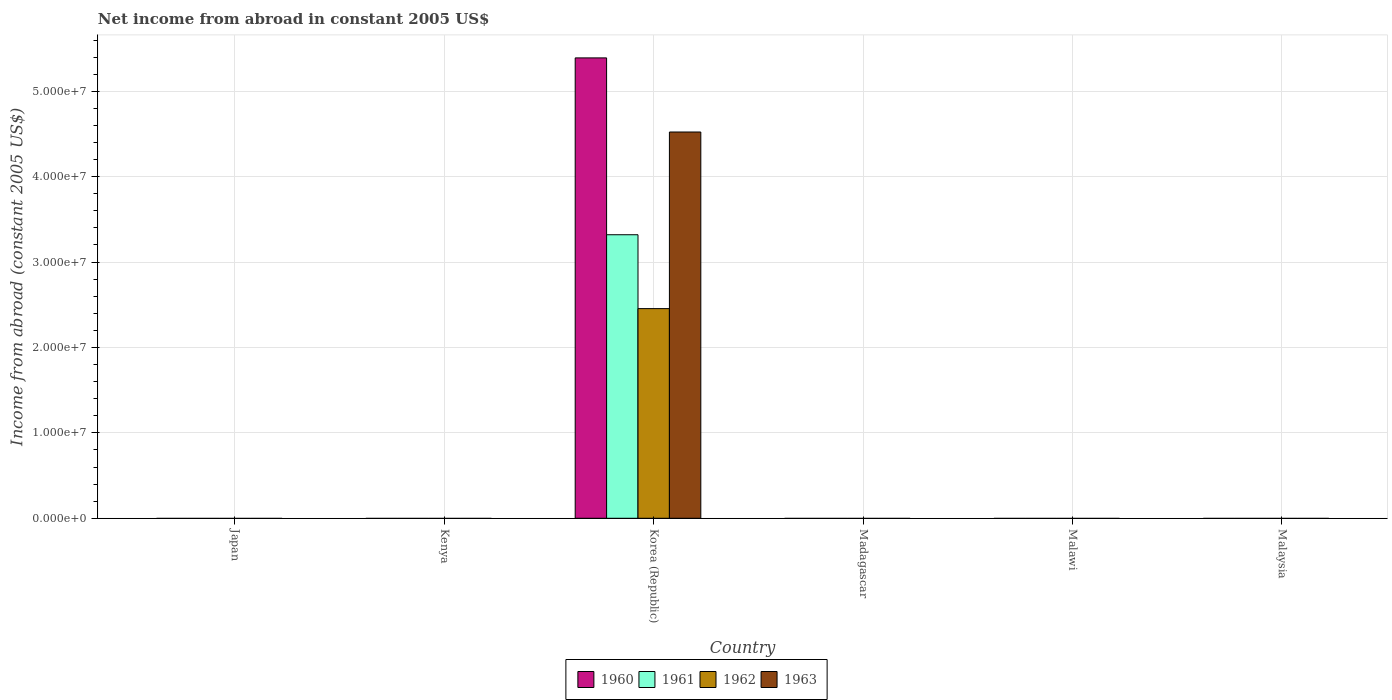How many different coloured bars are there?
Make the answer very short. 4. Are the number of bars on each tick of the X-axis equal?
Provide a succinct answer. No. How many bars are there on the 4th tick from the right?
Offer a very short reply. 4. What is the label of the 4th group of bars from the left?
Your answer should be very brief. Madagascar. What is the net income from abroad in 1962 in Korea (Republic)?
Provide a succinct answer. 2.45e+07. Across all countries, what is the maximum net income from abroad in 1960?
Your answer should be compact. 5.39e+07. Across all countries, what is the minimum net income from abroad in 1962?
Give a very brief answer. 0. In which country was the net income from abroad in 1962 maximum?
Your response must be concise. Korea (Republic). What is the total net income from abroad in 1963 in the graph?
Keep it short and to the point. 4.52e+07. What is the average net income from abroad in 1962 per country?
Provide a succinct answer. 4.09e+06. What is the difference between the net income from abroad of/in 1963 and net income from abroad of/in 1962 in Korea (Republic)?
Ensure brevity in your answer.  2.07e+07. In how many countries, is the net income from abroad in 1961 greater than 28000000 US$?
Make the answer very short. 1. What is the difference between the highest and the lowest net income from abroad in 1962?
Ensure brevity in your answer.  2.45e+07. Is it the case that in every country, the sum of the net income from abroad in 1962 and net income from abroad in 1961 is greater than the net income from abroad in 1960?
Your answer should be compact. No. What is the difference between two consecutive major ticks on the Y-axis?
Ensure brevity in your answer.  1.00e+07. Are the values on the major ticks of Y-axis written in scientific E-notation?
Your response must be concise. Yes. How many legend labels are there?
Your answer should be very brief. 4. How are the legend labels stacked?
Your answer should be compact. Horizontal. What is the title of the graph?
Make the answer very short. Net income from abroad in constant 2005 US$. Does "1972" appear as one of the legend labels in the graph?
Make the answer very short. No. What is the label or title of the X-axis?
Give a very brief answer. Country. What is the label or title of the Y-axis?
Ensure brevity in your answer.  Income from abroad (constant 2005 US$). What is the Income from abroad (constant 2005 US$) in 1960 in Japan?
Offer a terse response. 0. What is the Income from abroad (constant 2005 US$) of 1961 in Japan?
Your answer should be very brief. 0. What is the Income from abroad (constant 2005 US$) of 1962 in Japan?
Give a very brief answer. 0. What is the Income from abroad (constant 2005 US$) of 1963 in Japan?
Provide a short and direct response. 0. What is the Income from abroad (constant 2005 US$) in 1961 in Kenya?
Your answer should be compact. 0. What is the Income from abroad (constant 2005 US$) in 1963 in Kenya?
Provide a short and direct response. 0. What is the Income from abroad (constant 2005 US$) in 1960 in Korea (Republic)?
Keep it short and to the point. 5.39e+07. What is the Income from abroad (constant 2005 US$) of 1961 in Korea (Republic)?
Your answer should be very brief. 3.32e+07. What is the Income from abroad (constant 2005 US$) in 1962 in Korea (Republic)?
Offer a terse response. 2.45e+07. What is the Income from abroad (constant 2005 US$) in 1963 in Korea (Republic)?
Your answer should be compact. 4.52e+07. What is the Income from abroad (constant 2005 US$) in 1960 in Madagascar?
Provide a succinct answer. 0. What is the Income from abroad (constant 2005 US$) in 1961 in Madagascar?
Keep it short and to the point. 0. What is the Income from abroad (constant 2005 US$) of 1963 in Madagascar?
Provide a succinct answer. 0. What is the Income from abroad (constant 2005 US$) in 1960 in Malawi?
Give a very brief answer. 0. What is the Income from abroad (constant 2005 US$) in 1960 in Malaysia?
Provide a succinct answer. 0. What is the Income from abroad (constant 2005 US$) in 1961 in Malaysia?
Your response must be concise. 0. What is the Income from abroad (constant 2005 US$) of 1963 in Malaysia?
Provide a succinct answer. 0. Across all countries, what is the maximum Income from abroad (constant 2005 US$) in 1960?
Ensure brevity in your answer.  5.39e+07. Across all countries, what is the maximum Income from abroad (constant 2005 US$) of 1961?
Your response must be concise. 3.32e+07. Across all countries, what is the maximum Income from abroad (constant 2005 US$) of 1962?
Your answer should be compact. 2.45e+07. Across all countries, what is the maximum Income from abroad (constant 2005 US$) in 1963?
Offer a very short reply. 4.52e+07. Across all countries, what is the minimum Income from abroad (constant 2005 US$) in 1960?
Your response must be concise. 0. Across all countries, what is the minimum Income from abroad (constant 2005 US$) of 1962?
Give a very brief answer. 0. What is the total Income from abroad (constant 2005 US$) in 1960 in the graph?
Make the answer very short. 5.39e+07. What is the total Income from abroad (constant 2005 US$) in 1961 in the graph?
Offer a terse response. 3.32e+07. What is the total Income from abroad (constant 2005 US$) in 1962 in the graph?
Give a very brief answer. 2.45e+07. What is the total Income from abroad (constant 2005 US$) in 1963 in the graph?
Your answer should be compact. 4.52e+07. What is the average Income from abroad (constant 2005 US$) of 1960 per country?
Keep it short and to the point. 8.98e+06. What is the average Income from abroad (constant 2005 US$) of 1961 per country?
Keep it short and to the point. 5.53e+06. What is the average Income from abroad (constant 2005 US$) of 1962 per country?
Give a very brief answer. 4.09e+06. What is the average Income from abroad (constant 2005 US$) of 1963 per country?
Keep it short and to the point. 7.54e+06. What is the difference between the Income from abroad (constant 2005 US$) in 1960 and Income from abroad (constant 2005 US$) in 1961 in Korea (Republic)?
Offer a very short reply. 2.07e+07. What is the difference between the Income from abroad (constant 2005 US$) of 1960 and Income from abroad (constant 2005 US$) of 1962 in Korea (Republic)?
Offer a very short reply. 2.94e+07. What is the difference between the Income from abroad (constant 2005 US$) in 1960 and Income from abroad (constant 2005 US$) in 1963 in Korea (Republic)?
Your answer should be compact. 8.68e+06. What is the difference between the Income from abroad (constant 2005 US$) of 1961 and Income from abroad (constant 2005 US$) of 1962 in Korea (Republic)?
Make the answer very short. 8.65e+06. What is the difference between the Income from abroad (constant 2005 US$) in 1961 and Income from abroad (constant 2005 US$) in 1963 in Korea (Republic)?
Give a very brief answer. -1.20e+07. What is the difference between the Income from abroad (constant 2005 US$) of 1962 and Income from abroad (constant 2005 US$) of 1963 in Korea (Republic)?
Your answer should be compact. -2.07e+07. What is the difference between the highest and the lowest Income from abroad (constant 2005 US$) of 1960?
Make the answer very short. 5.39e+07. What is the difference between the highest and the lowest Income from abroad (constant 2005 US$) in 1961?
Ensure brevity in your answer.  3.32e+07. What is the difference between the highest and the lowest Income from abroad (constant 2005 US$) of 1962?
Your answer should be compact. 2.45e+07. What is the difference between the highest and the lowest Income from abroad (constant 2005 US$) in 1963?
Your answer should be very brief. 4.52e+07. 